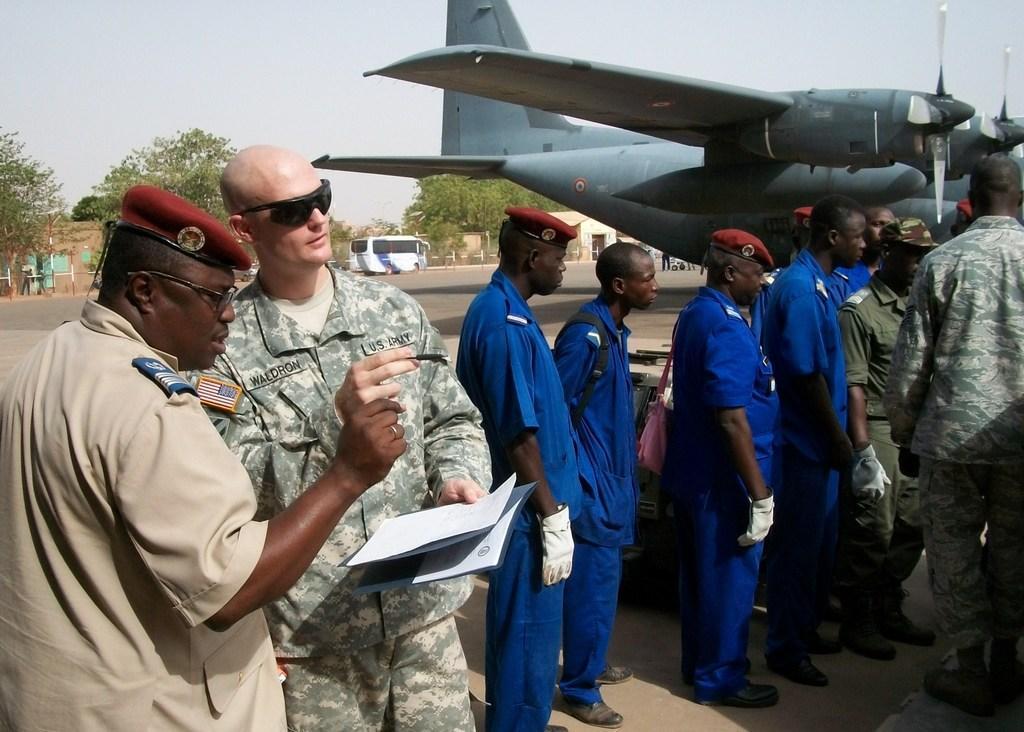Describe this image in one or two sentences. In this image there are two persons standing, a person holding the papers and a file, and in the background there are group of people standing, an airplane, bus , sheds, trees, poles, sky. 